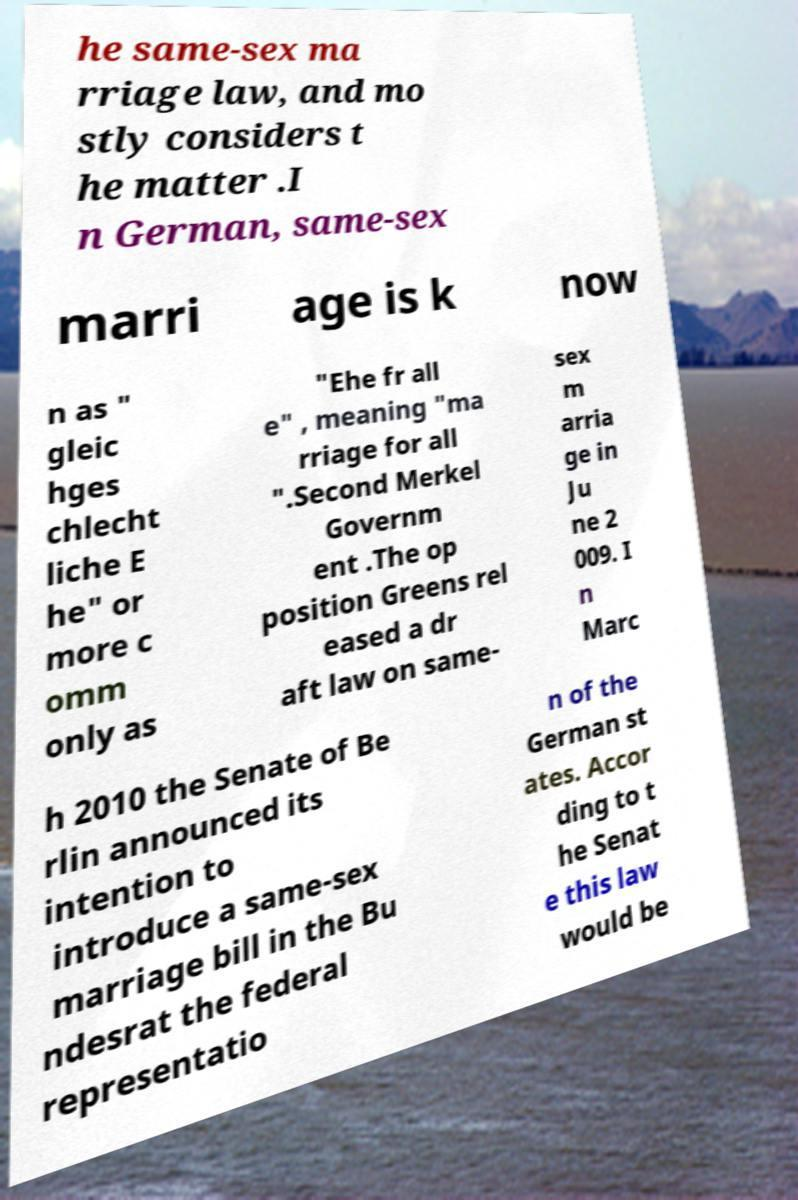Can you read and provide the text displayed in the image?This photo seems to have some interesting text. Can you extract and type it out for me? he same-sex ma rriage law, and mo stly considers t he matter .I n German, same-sex marri age is k now n as " gleic hges chlecht liche E he" or more c omm only as "Ehe fr all e" , meaning "ma rriage for all ".Second Merkel Governm ent .The op position Greens rel eased a dr aft law on same- sex m arria ge in Ju ne 2 009. I n Marc h 2010 the Senate of Be rlin announced its intention to introduce a same-sex marriage bill in the Bu ndesrat the federal representatio n of the German st ates. Accor ding to t he Senat e this law would be 